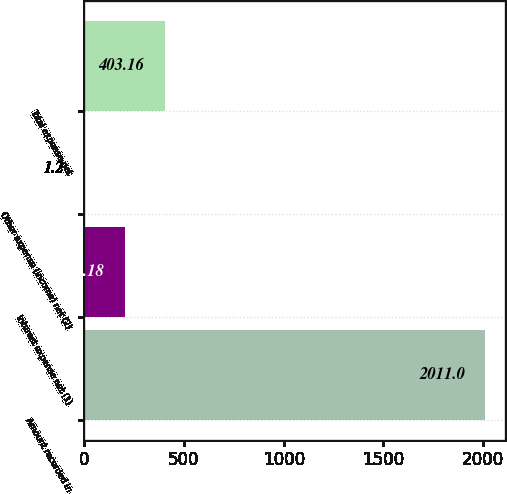Convert chart to OTSL. <chart><loc_0><loc_0><loc_500><loc_500><bar_chart><fcel>Amount recorded in<fcel>Interest expense net (1)<fcel>Other expense (income) net (2)<fcel>Total expense net<nl><fcel>2011<fcel>202.18<fcel>1.2<fcel>403.16<nl></chart> 